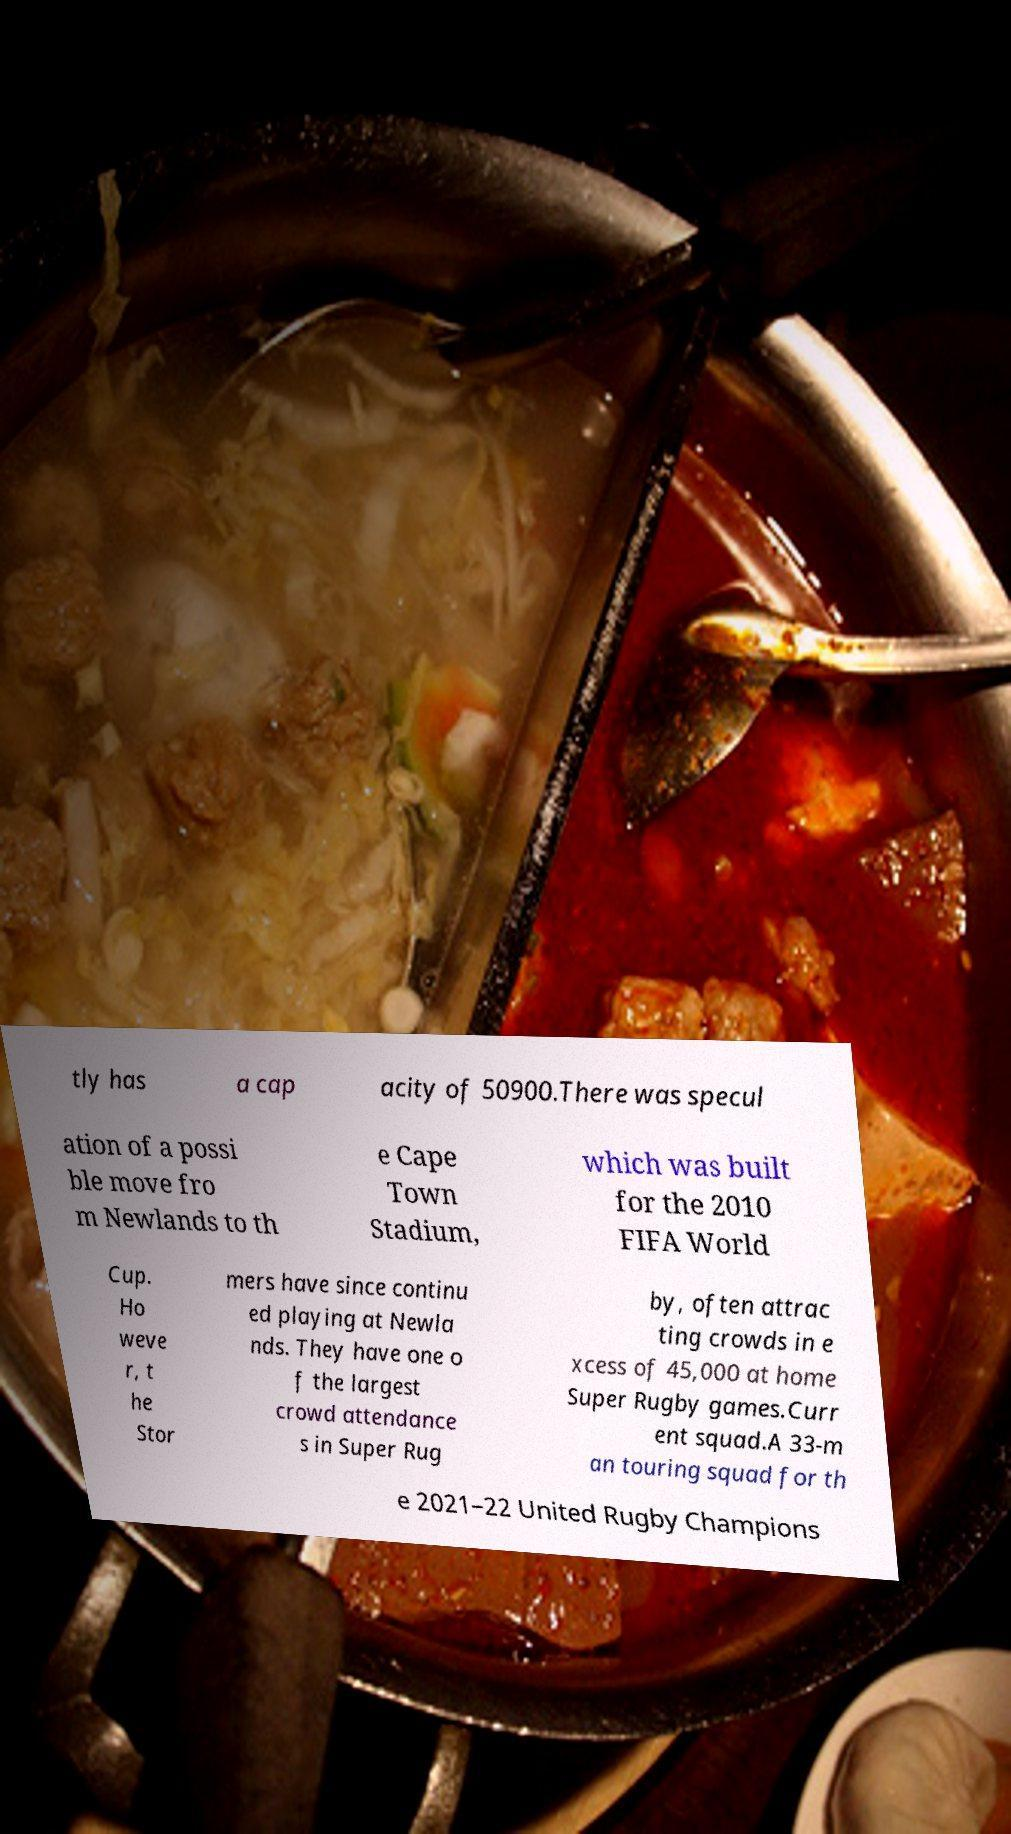I need the written content from this picture converted into text. Can you do that? tly has a cap acity of 50900.There was specul ation of a possi ble move fro m Newlands to th e Cape Town Stadium, which was built for the 2010 FIFA World Cup. Ho weve r, t he Stor mers have since continu ed playing at Newla nds. They have one o f the largest crowd attendance s in Super Rug by, often attrac ting crowds in e xcess of 45,000 at home Super Rugby games.Curr ent squad.A 33-m an touring squad for th e 2021–22 United Rugby Champions 